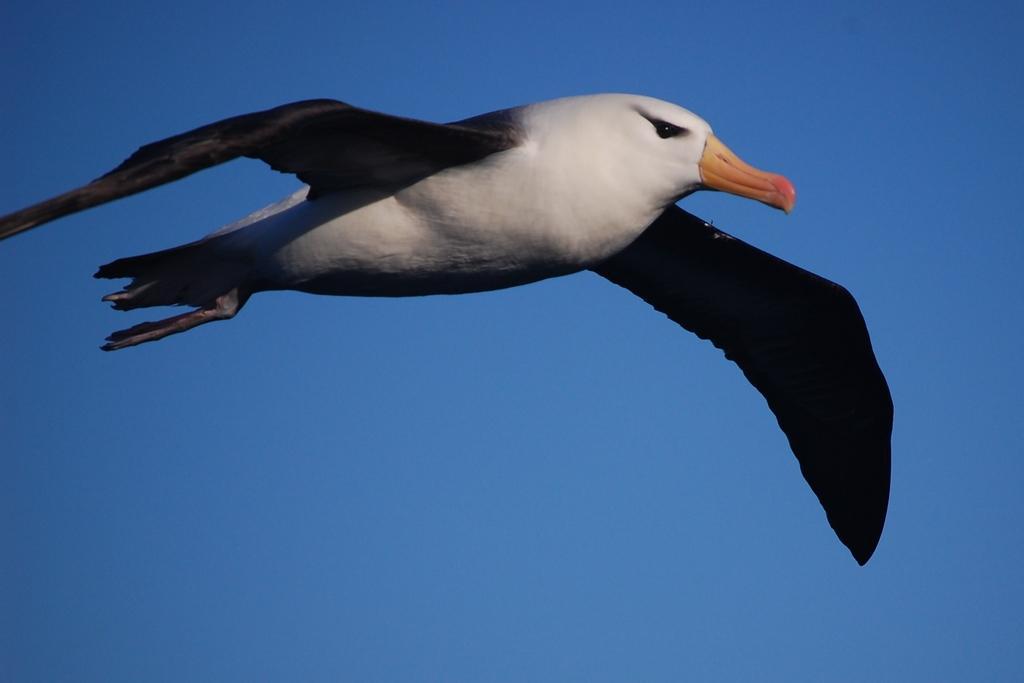How would you summarize this image in a sentence or two? In this image we can see a bird flying in the sky. 